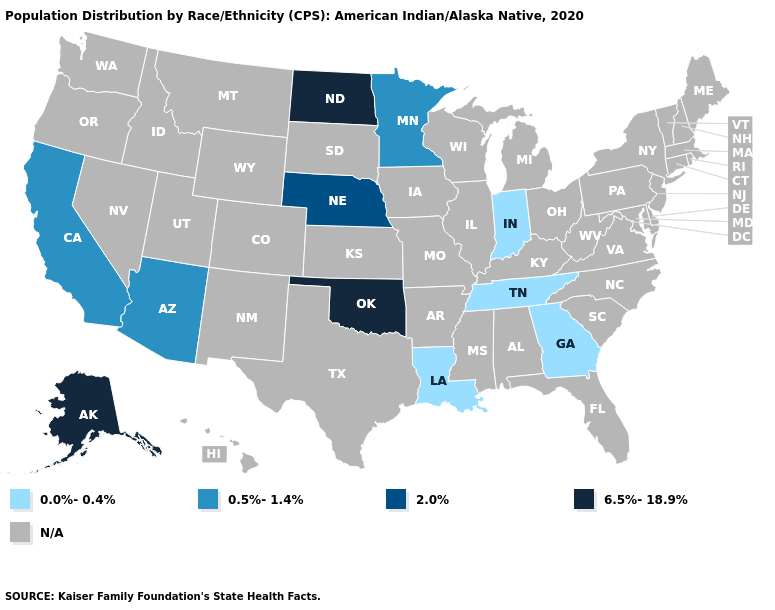Is the legend a continuous bar?
Give a very brief answer. No. Name the states that have a value in the range 6.5%-18.9%?
Answer briefly. Alaska, North Dakota, Oklahoma. What is the highest value in the USA?
Write a very short answer. 6.5%-18.9%. Name the states that have a value in the range 6.5%-18.9%?
Give a very brief answer. Alaska, North Dakota, Oklahoma. What is the highest value in the USA?
Answer briefly. 6.5%-18.9%. Among the states that border Iowa , does Nebraska have the highest value?
Concise answer only. Yes. What is the value of New Jersey?
Quick response, please. N/A. What is the lowest value in states that border North Dakota?
Give a very brief answer. 0.5%-1.4%. Among the states that border North Dakota , which have the lowest value?
Quick response, please. Minnesota. Is the legend a continuous bar?
Be succinct. No. Which states have the highest value in the USA?
Short answer required. Alaska, North Dakota, Oklahoma. What is the value of Vermont?
Answer briefly. N/A. Does the map have missing data?
Give a very brief answer. Yes. What is the value of South Dakota?
Concise answer only. N/A. 